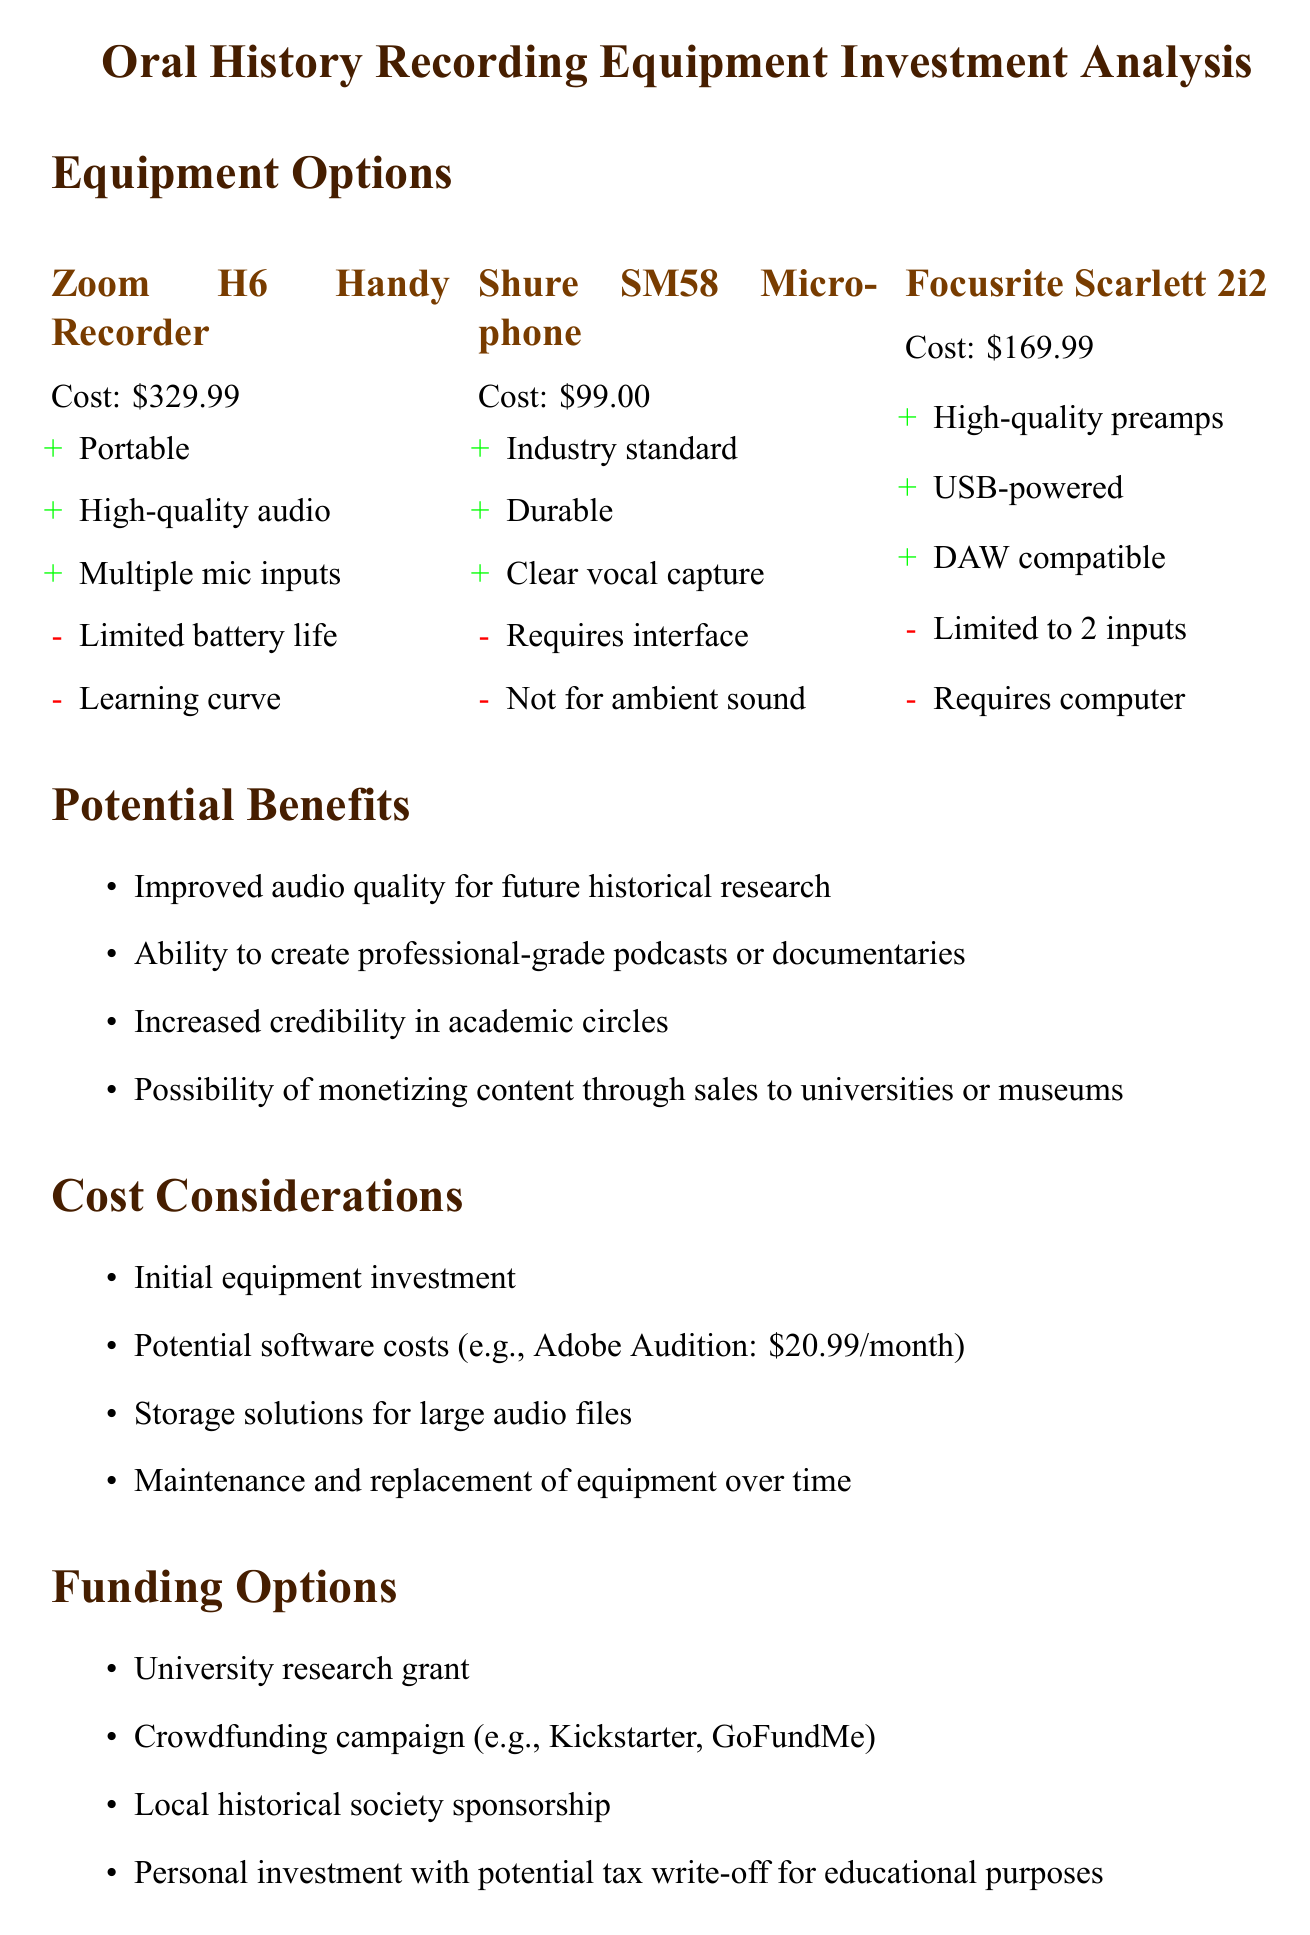What is the title of the project? The title of the project is clearly stated at the beginning of the document.
Answer: Oral History Recording Equipment Investment Analysis How much does the Zoom H6 Handy Recorder cost? The cost is listed under the equipment options section of the document.
Answer: 329.99 What is one pro of the Shure SM58 Microphone? The document lists pros and cons for each equipment option.
Answer: Industry standard What is one potential benefit mentioned? The benefits section outlines several advantages of the investment.
Answer: Improved audio quality for future historical research What is one funding option available? The funding options listed provide various ways to finance the project.
Answer: University research grant How much does Adobe Audition cost per month? The document specifies potential software costs in the cost considerations section.
Answer: 20.99 What is one long-term value of the investment? The long-term value section highlights benefits from the investment.
Answer: Creation of a unique historical archive What is a con of the Focusrite Scarlett 2i2? Cons for each equipment option are provided in the document.
Answer: Limited to 2 inputs What is one potential use for the recorded interviews? The potential benefits outline the uses of the recorded interviews.
Answer: Ability to create professional-grade podcasts or documentaries 